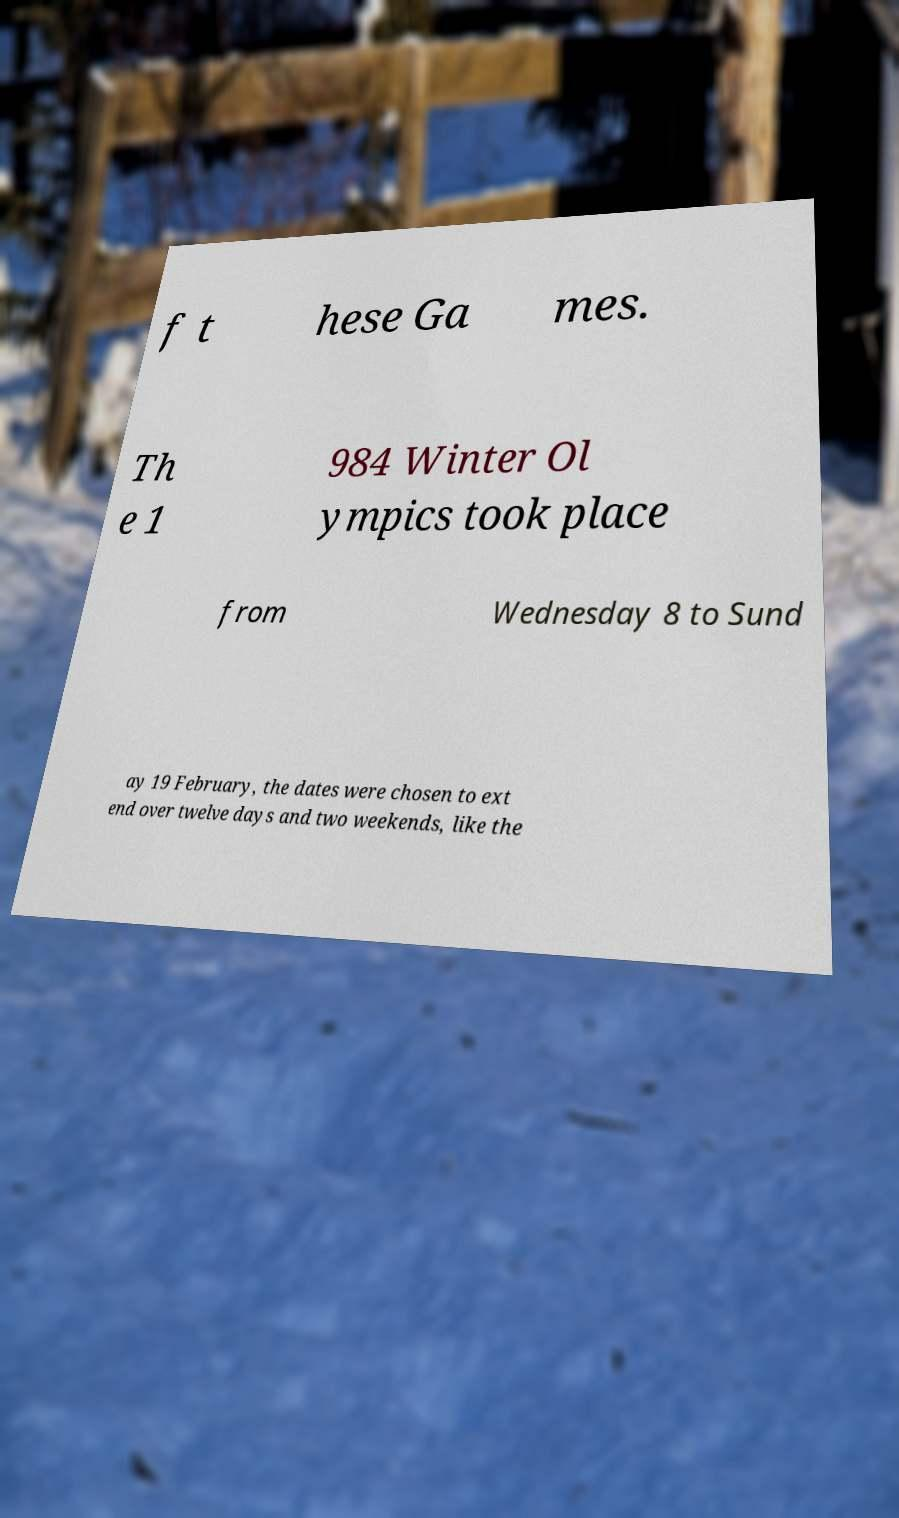Could you assist in decoding the text presented in this image and type it out clearly? f t hese Ga mes. Th e 1 984 Winter Ol ympics took place from Wednesday 8 to Sund ay 19 February, the dates were chosen to ext end over twelve days and two weekends, like the 